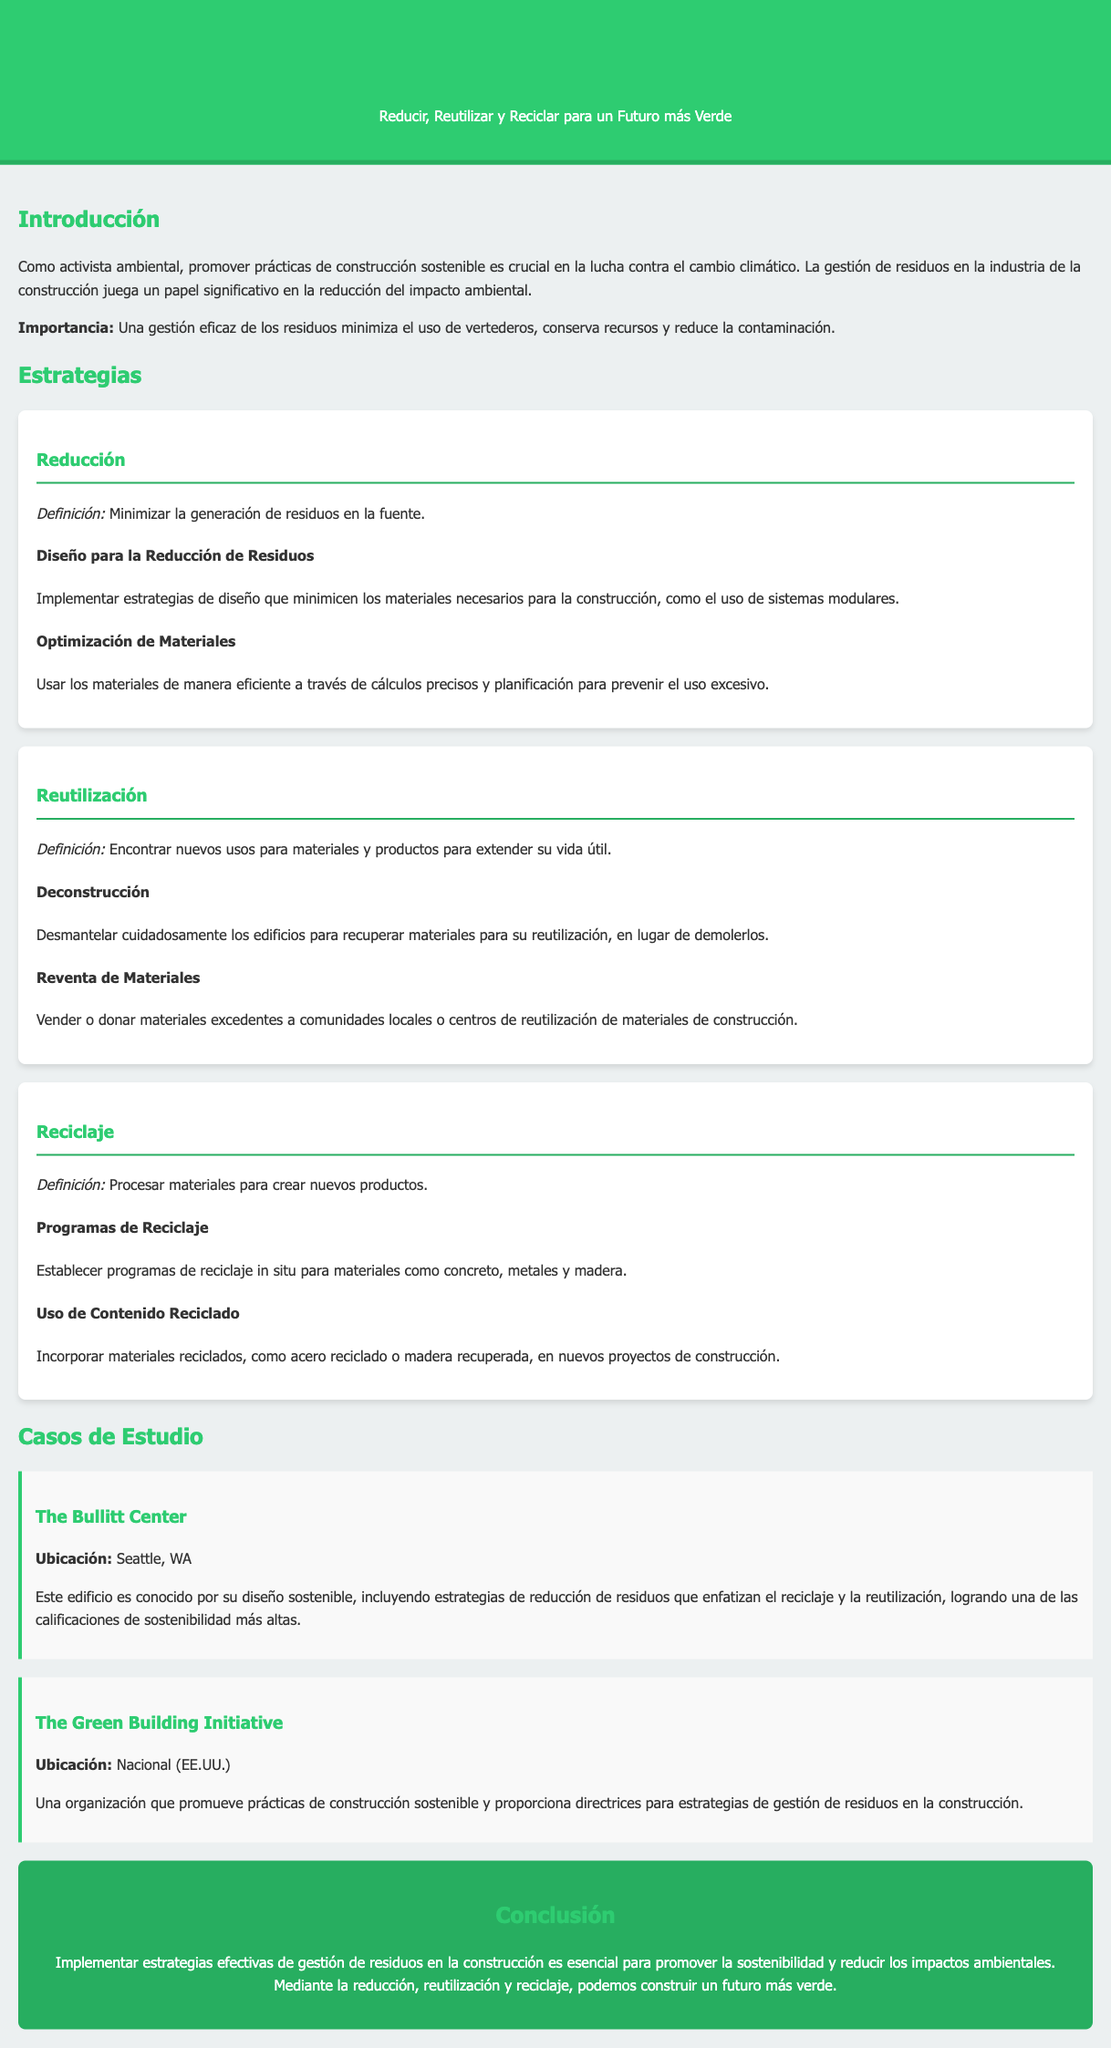¿Qué se busca lograr con la gestión de residuos en la construcción? La gestión de residuos busca minimizar el uso de vertederos, conservar recursos y reducir la contaminación.
Answer: Minimizar el uso de vertederos, conservar recursos y reducir la contaminación ¿Qué estrategia se define como minimizar la generación de residuos en la fuente? La definición de la estrategia que minimiza la generación de residuos en la fuente está en el apartado de Reducción.
Answer: Reducción ¿Cuál es un ejemplo de una práctica de reutilización? La práctica de reutilización que se menciona es la de desmantelar edificios para recuperar materiales.
Answer: Deconstrucción ¿Cuál es un programa que se establece para reciclar materiales como concreto y madera? Se menciona que se deben establecer programas de reciclaje in situ en la estrategia de reciclaje.
Answer: Programas de Reciclaje ¿Qué edificio es conocido por su diseño sostenible en Seattle, WA? El edificio destacado en Seattle, WA, por su diseño sostenible es el Bullitt Center.
Answer: The Bullitt Center ¿Cuál es el enfoque principal de The Green Building Initiative? The Green Building Initiative promueve prácticas de construcción sostenible y facilita directrices de gestión de residuos.
Answer: Promover prácticas de construcción sostenible ¿Qué tipo de información se presenta en la sección de Casos de Estudio? La sección de Casos de Estudio presenta ejemplos de edificios y organizaciones que implementan prácticas sostenibles.
Answer: Ejemplos de edificios y organizaciones ¿Cuál es el mensaje principal de la conclusión del manual? El mensaje principal enfatiza la importancia de implementar estrategias de gestión de residuos para promover la sostenibilidad.
Answer: Implementar estrategias de gestión de residuos es esencial 